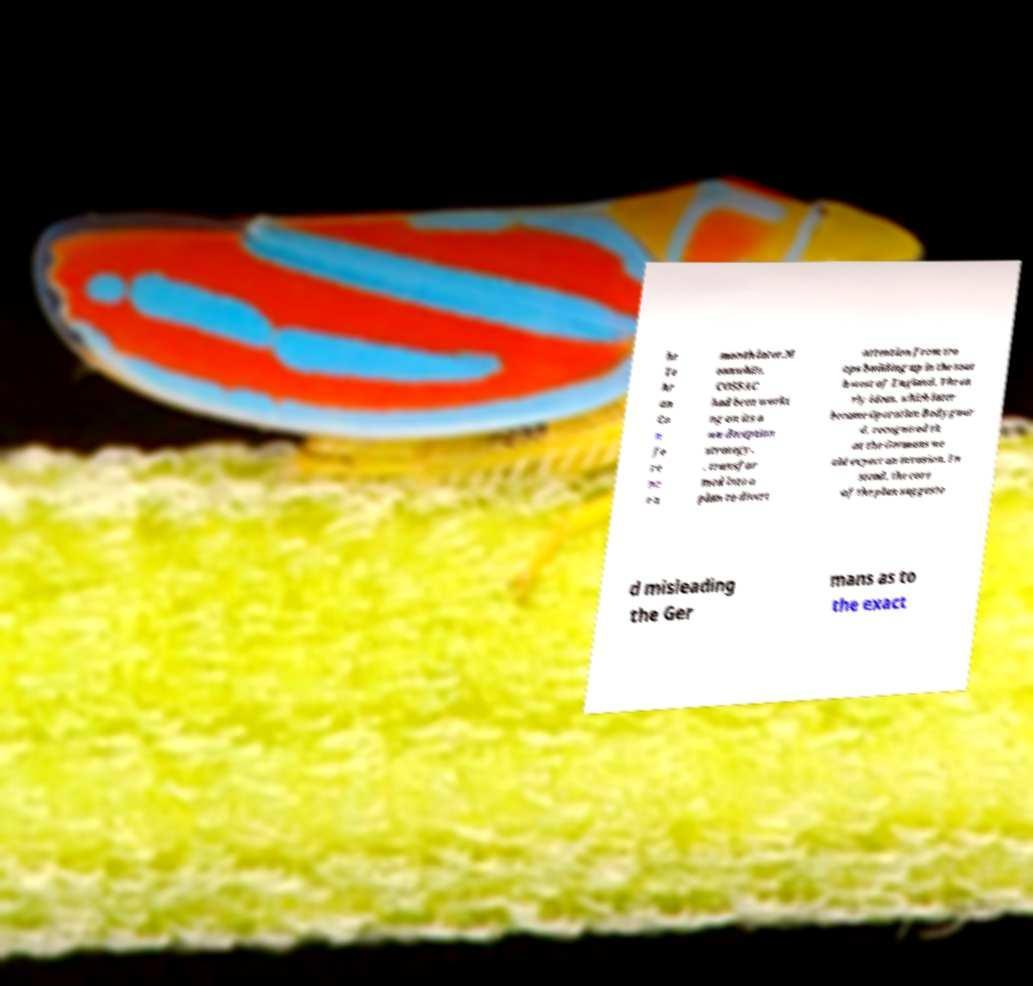There's text embedded in this image that I need extracted. Can you transcribe it verbatim? he Te hr an Co n fe re nc e a month later.M eanwhile, COSSAC had been worki ng on its o wn deception strategy, , transfor med into a plan to divert attention from tro ops building up in the sout h-west of England. The ea rly ideas, which later became Operation Bodyguar d, recognised th at the Germans wo uld expect an invasion. In stead, the core of the plan suggeste d misleading the Ger mans as to the exact 